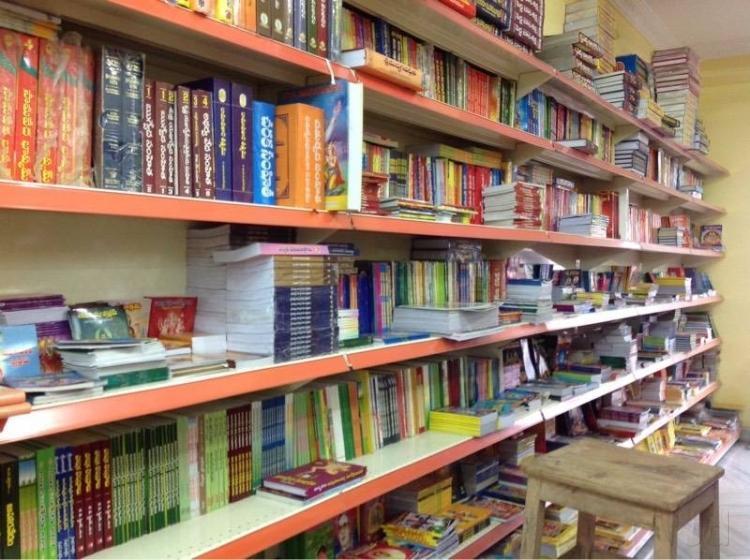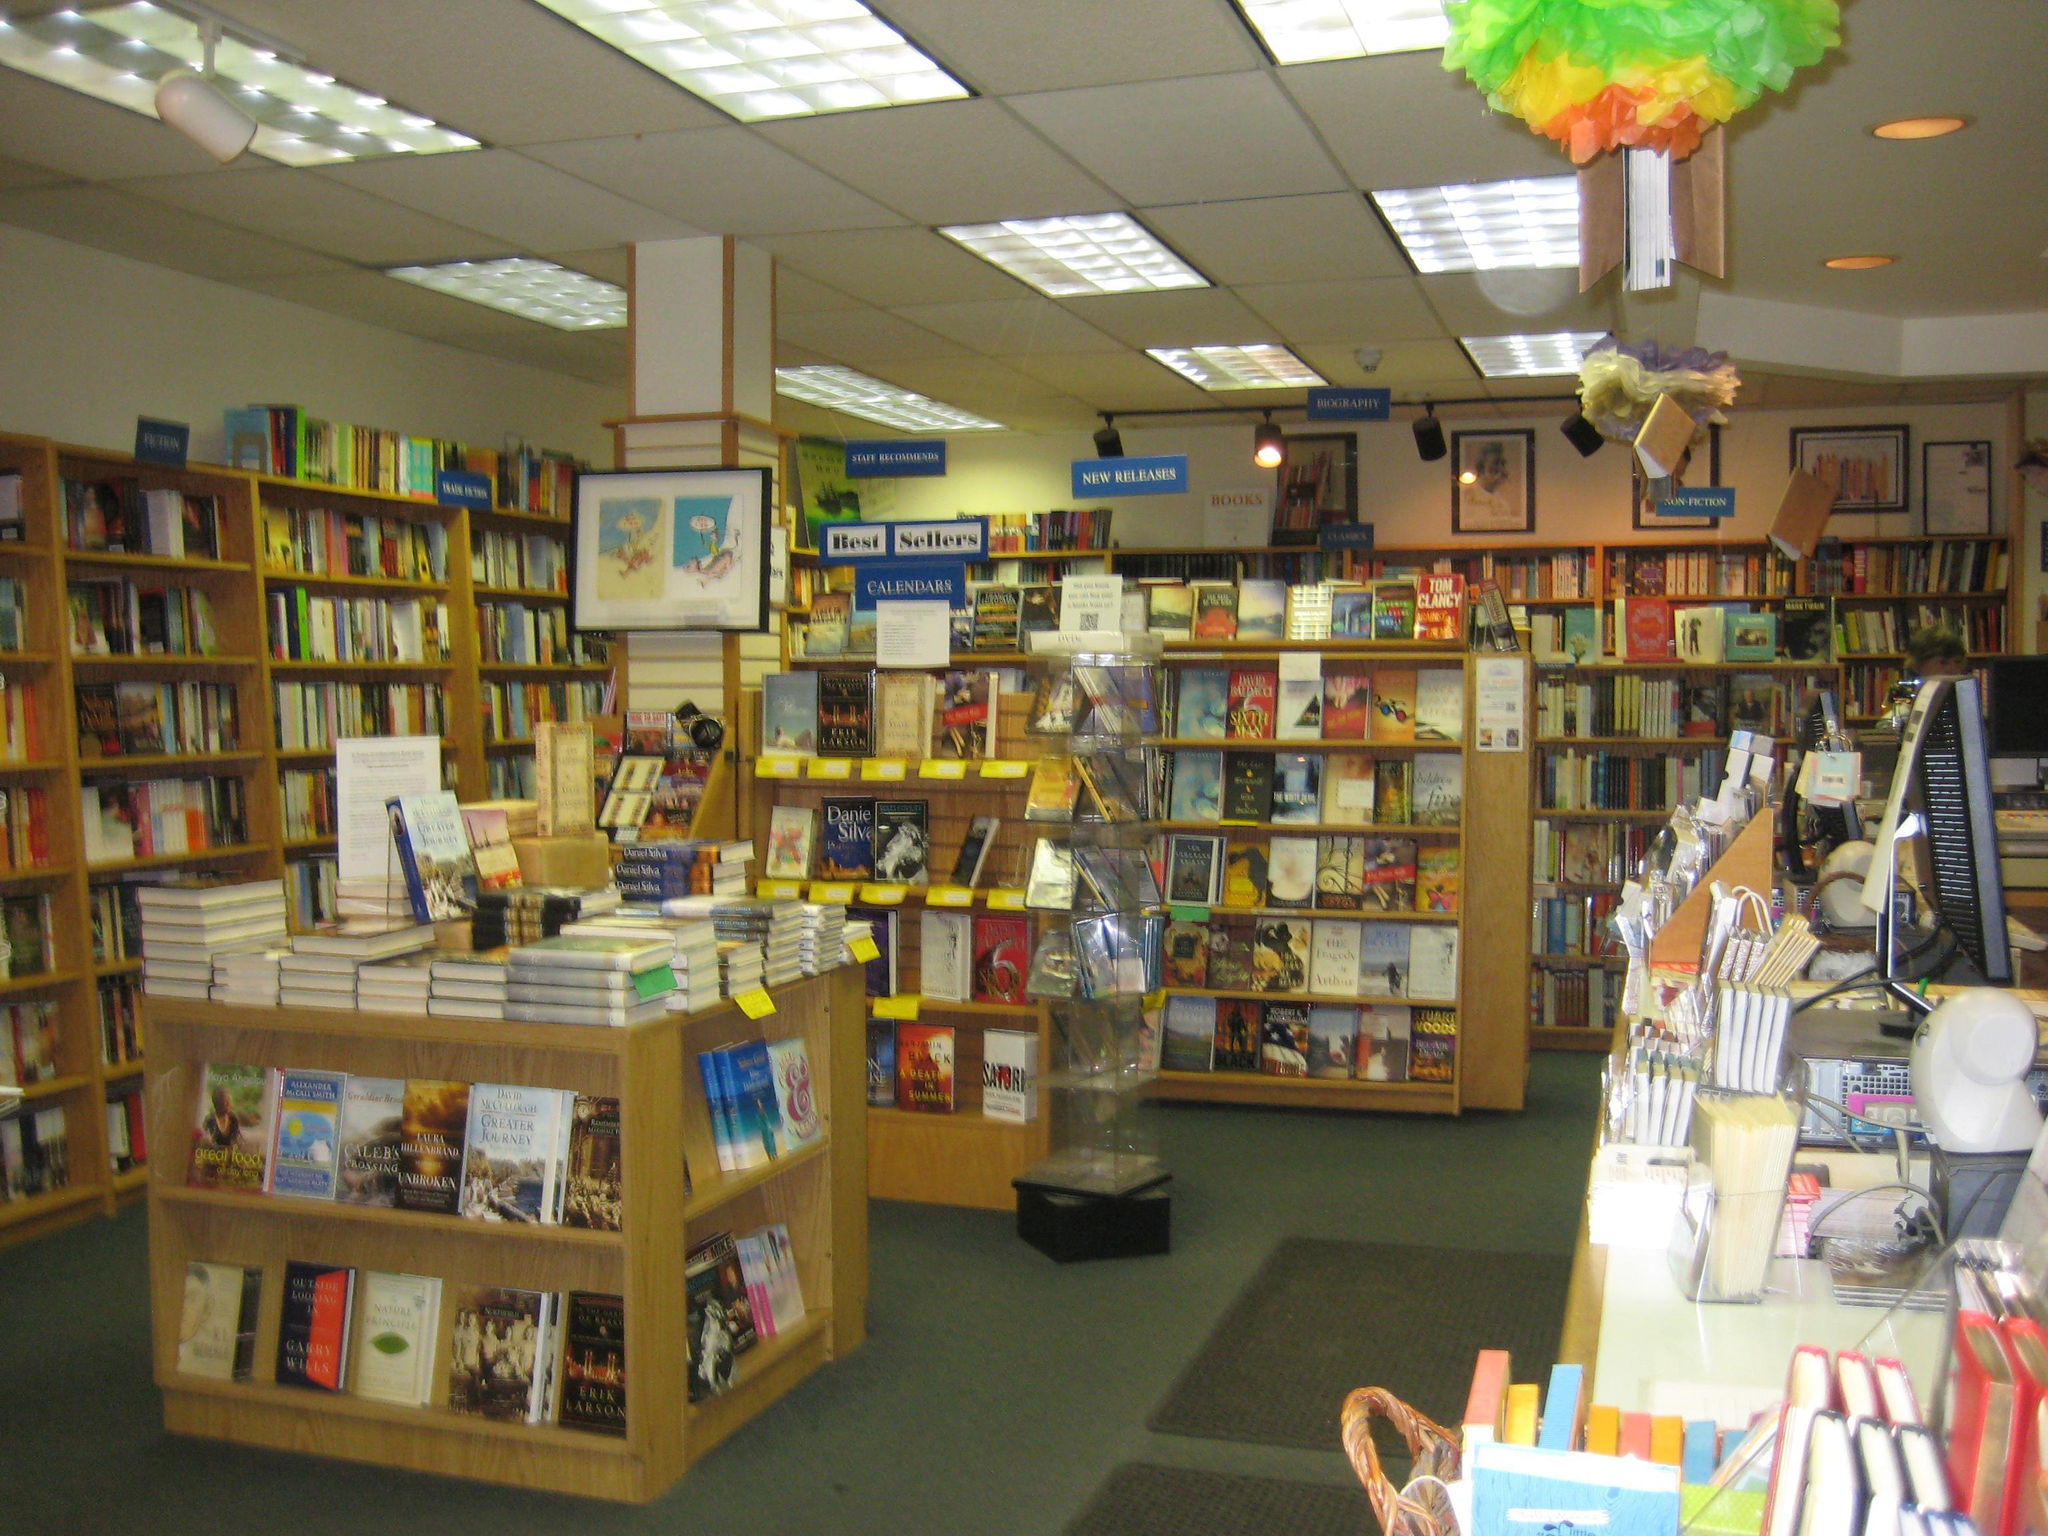The first image is the image on the left, the second image is the image on the right. Given the left and right images, does the statement "At least 2 people are shopping for books in the bookstore." hold true? Answer yes or no. No. The first image is the image on the left, the second image is the image on the right. Considering the images on both sides, is "People stand in the book store in the image on the right." valid? Answer yes or no. No. 